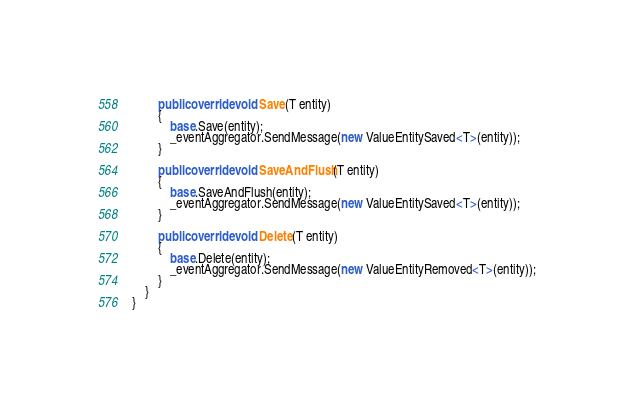Convert code to text. <code><loc_0><loc_0><loc_500><loc_500><_C#_>
        public override void Save(T entity)
        {
            base.Save(entity);
            _eventAggregator.SendMessage(new ValueEntitySaved<T>(entity));
        }

        public override void SaveAndFlush(T entity)
        {
            base.SaveAndFlush(entity);
            _eventAggregator.SendMessage(new ValueEntitySaved<T>(entity));
        }

        public override void Delete(T entity)
        {
            base.Delete(entity);
            _eventAggregator.SendMessage(new ValueEntityRemoved<T>(entity));
        }
    }
}</code> 